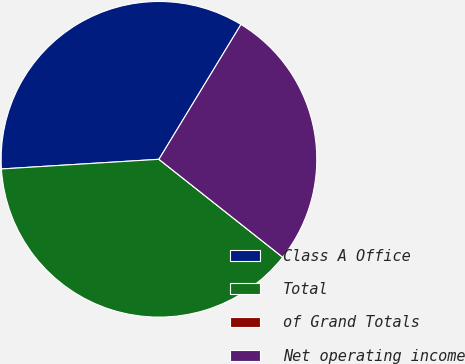<chart> <loc_0><loc_0><loc_500><loc_500><pie_chart><fcel>Class A Office<fcel>Total<fcel>of Grand Totals<fcel>Net operating income<nl><fcel>34.67%<fcel>38.37%<fcel>0.0%<fcel>26.95%<nl></chart> 